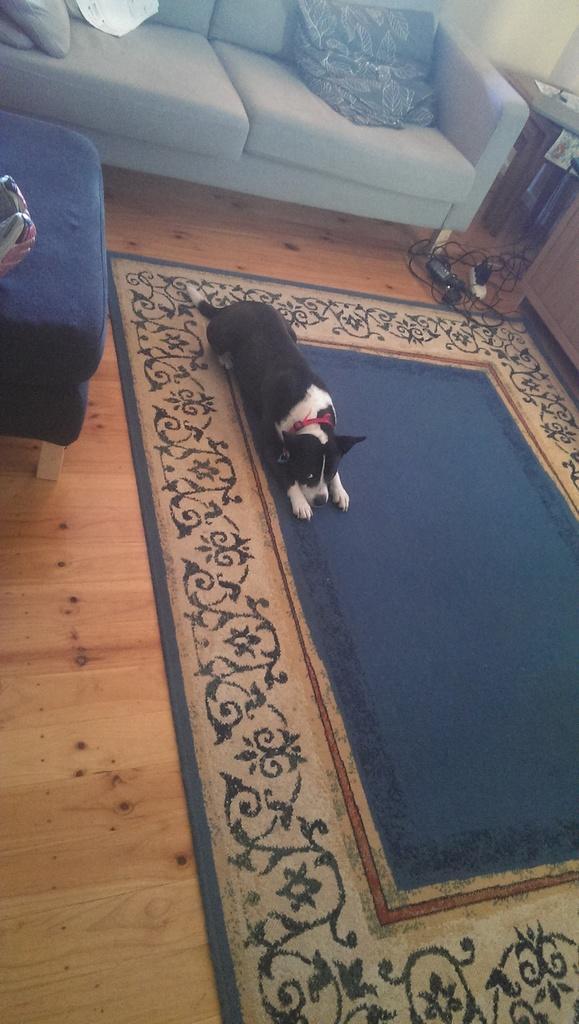Could you give a brief overview of what you see in this image? There is a dog on carpet which is on the floor. In the background there are sofas,wall and a table. 